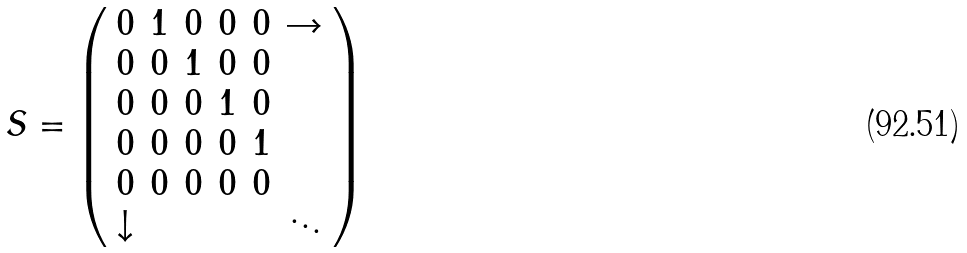<formula> <loc_0><loc_0><loc_500><loc_500>S = \left ( \begin{array} { c c c c c c } 0 & 1 & 0 & 0 & 0 & \rightarrow \\ 0 & 0 & 1 & 0 & 0 & \\ 0 & 0 & 0 & 1 & 0 & \\ 0 & 0 & 0 & 0 & 1 & \\ 0 & 0 & 0 & 0 & 0 & \\ \downarrow & & & & & \ddots \end{array} \right )</formula> 